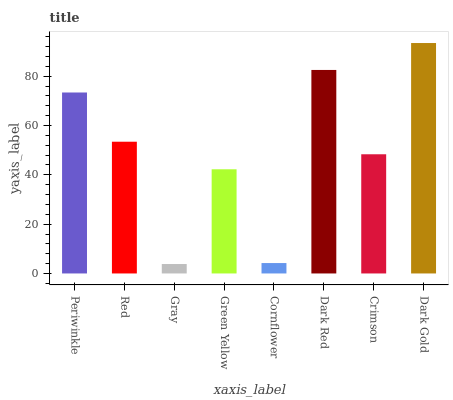Is Gray the minimum?
Answer yes or no. Yes. Is Dark Gold the maximum?
Answer yes or no. Yes. Is Red the minimum?
Answer yes or no. No. Is Red the maximum?
Answer yes or no. No. Is Periwinkle greater than Red?
Answer yes or no. Yes. Is Red less than Periwinkle?
Answer yes or no. Yes. Is Red greater than Periwinkle?
Answer yes or no. No. Is Periwinkle less than Red?
Answer yes or no. No. Is Red the high median?
Answer yes or no. Yes. Is Crimson the low median?
Answer yes or no. Yes. Is Dark Gold the high median?
Answer yes or no. No. Is Green Yellow the low median?
Answer yes or no. No. 